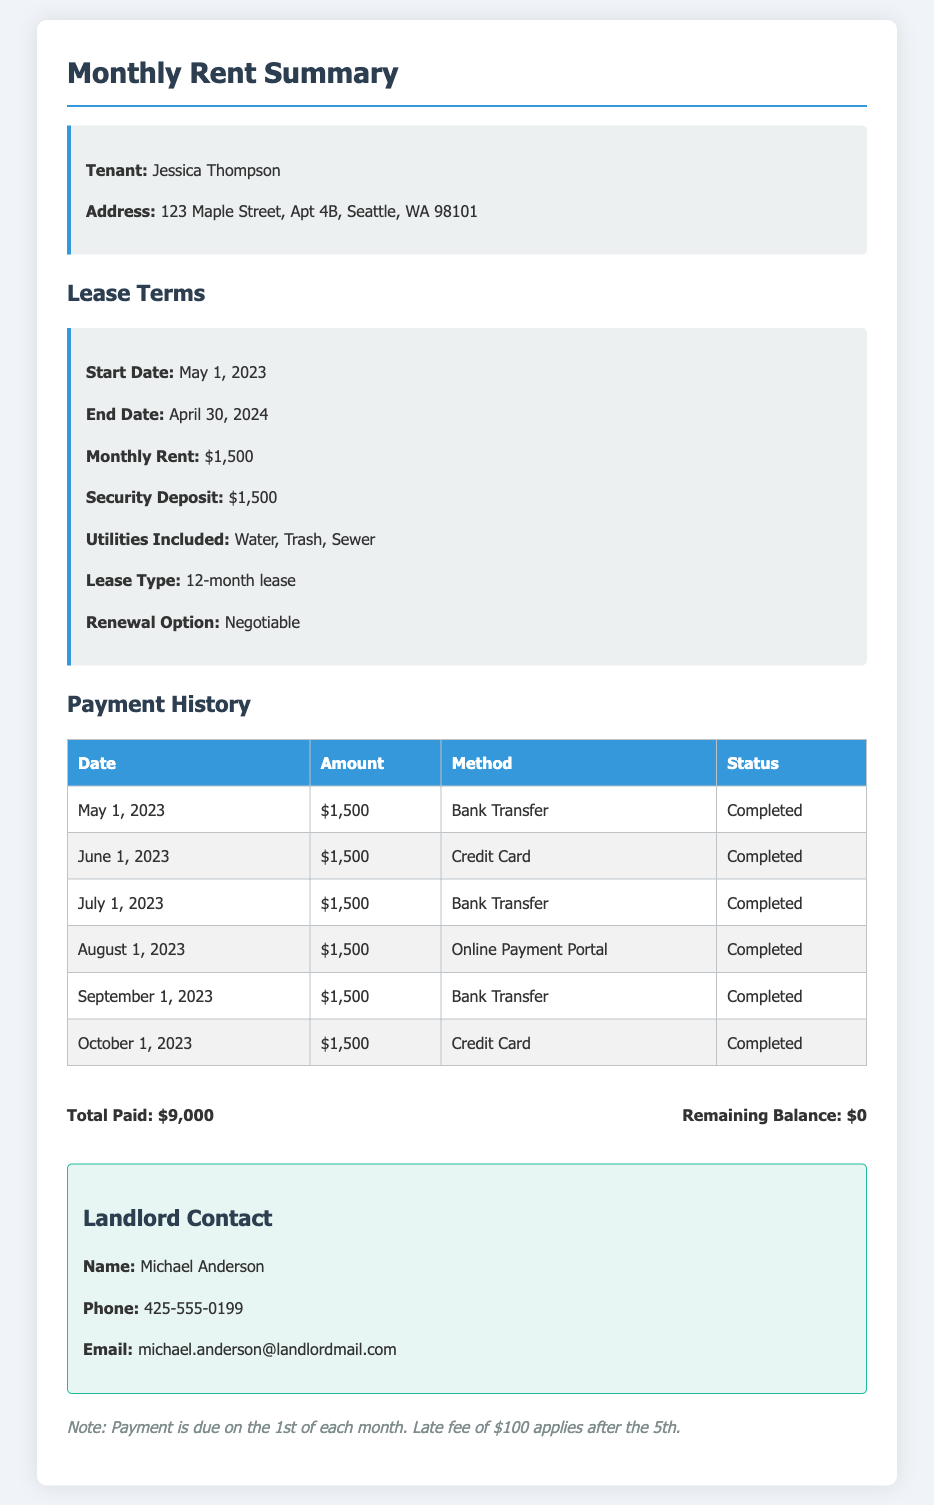What is the tenant's name? The tenant's name is listed at the top of the document under the tenant information section.
Answer: Jessica Thompson What is the monthly rent? The monthly rent is specified in the lease terms section of the document.
Answer: $1,500 What is the security deposit amount? The security deposit amount is stated in the lease terms section as well.
Answer: $1,500 When does the lease end? The lease end date is mentioned in the lease terms section of the document.
Answer: April 30, 2024 How much total rent has been paid? The total rent paid is calculated based on the payment history provided in the document.
Answer: $9,000 What is the payment status for October 1, 2023? The status for each payment date is provided in the payment history table.
Answer: Completed What payment methods were used? The document lists payment methods used in the payment history section.
Answer: Bank Transfer, Credit Card, Online Payment Portal Is there a late fee? The notes section mentions the policy regarding late fees.
Answer: Yes Who is the landlord? The landlord's name is provided in the landlord contact section of the document.
Answer: Michael Anderson 